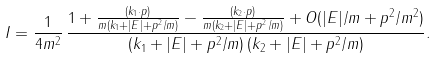Convert formula to latex. <formula><loc_0><loc_0><loc_500><loc_500>I = \frac { 1 } { 4 m ^ { 2 } } \, \frac { 1 + \frac { ( { k } _ { 1 } \cdot { p } ) } { m ( k _ { 1 } + | E | + { p } ^ { 2 } / m ) } - \frac { ( { k } _ { 2 } \cdot { p } ) } { m ( k _ { 2 } + | E | + { p } ^ { 2 } / m ) } + O ( | E | / m + { p } ^ { 2 } / m ^ { 2 } ) } { ( k _ { 1 } + | E | + { p } ^ { 2 } / m ) \, ( k _ { 2 } + | E | + { p } ^ { 2 } / m ) } .</formula> 